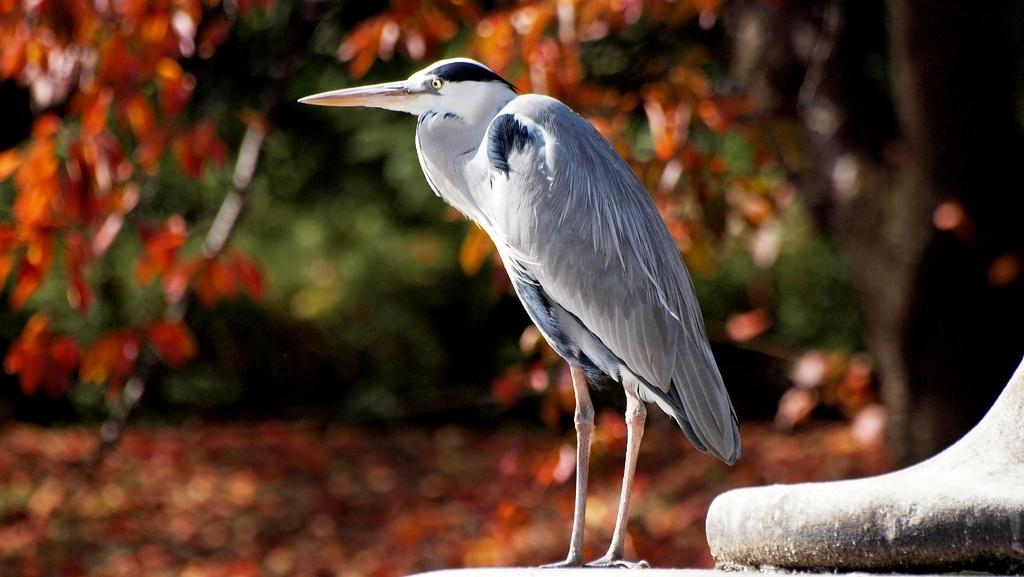What type of animal is in the image? There is a white color bird in the image. Where is the bird located in the image? The bird is in the front of the image. What can be seen in the background of the image? There are trees in the background of the image. How would you describe the background in the image? The background is slightly blurred. What year is depicted in the image? The image does not depict a specific year; it is a photograph of a bird and trees. 